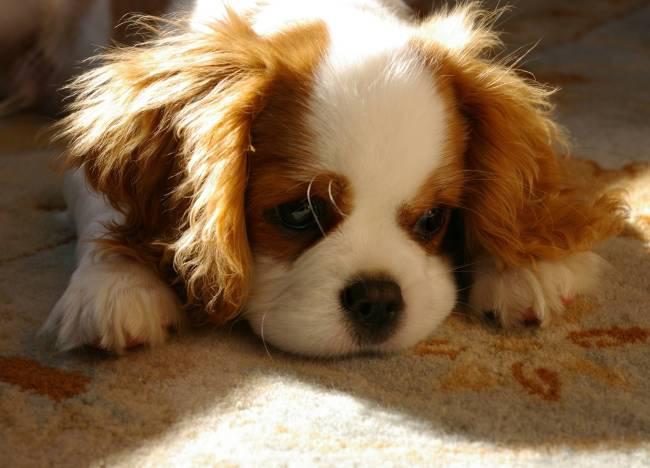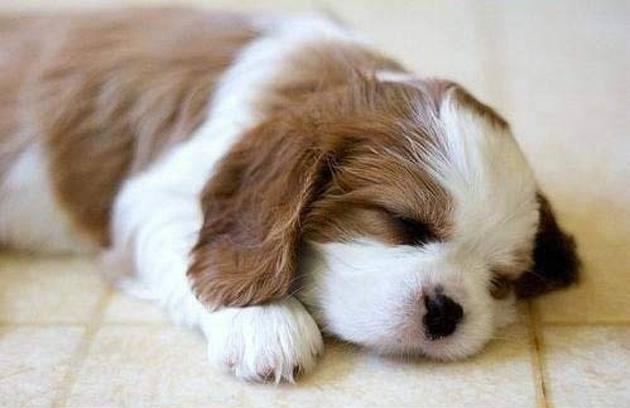The first image is the image on the left, the second image is the image on the right. For the images shown, is this caption "At least one dog is laying down." true? Answer yes or no. Yes. 